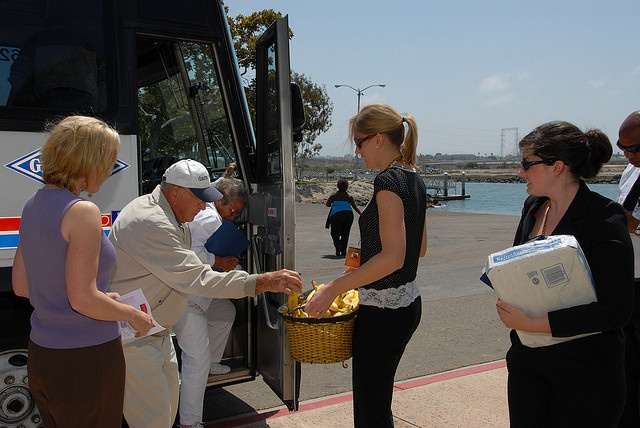Describe the objects in this image and their specific colors. I can see bus in black and gray tones, people in black, gray, and brown tones, people in black, gray, brown, and purple tones, people in black, brown, and gray tones, and people in black, gray, darkgray, and maroon tones in this image. 